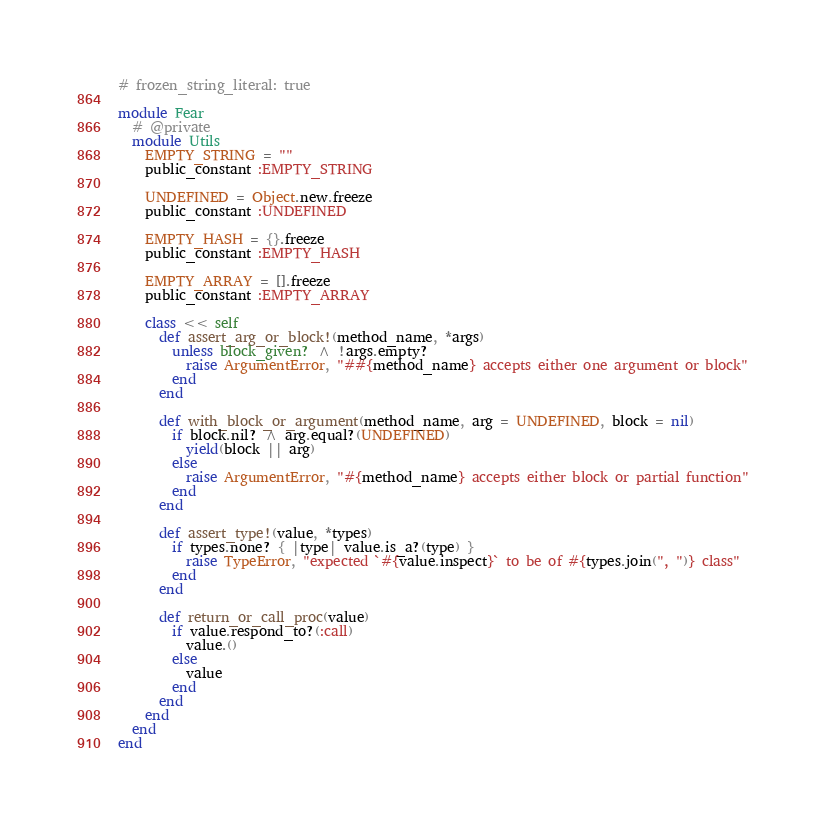Convert code to text. <code><loc_0><loc_0><loc_500><loc_500><_Ruby_># frozen_string_literal: true

module Fear
  # @private
  module Utils
    EMPTY_STRING = ""
    public_constant :EMPTY_STRING

    UNDEFINED = Object.new.freeze
    public_constant :UNDEFINED

    EMPTY_HASH = {}.freeze
    public_constant :EMPTY_HASH

    EMPTY_ARRAY = [].freeze
    public_constant :EMPTY_ARRAY

    class << self
      def assert_arg_or_block!(method_name, *args)
        unless block_given? ^ !args.empty?
          raise ArgumentError, "##{method_name} accepts either one argument or block"
        end
      end

      def with_block_or_argument(method_name, arg = UNDEFINED, block = nil)
        if block.nil? ^ arg.equal?(UNDEFINED)
          yield(block || arg)
        else
          raise ArgumentError, "#{method_name} accepts either block or partial function"
        end
      end

      def assert_type!(value, *types)
        if types.none? { |type| value.is_a?(type) }
          raise TypeError, "expected `#{value.inspect}` to be of #{types.join(", ")} class"
        end
      end

      def return_or_call_proc(value)
        if value.respond_to?(:call)
          value.()
        else
          value
        end
      end
    end
  end
end
</code> 